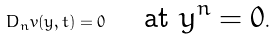Convert formula to latex. <formula><loc_0><loc_0><loc_500><loc_500>D _ { n } v ( y , t ) = 0 \quad \text { at $y^{n}=0$} .</formula> 